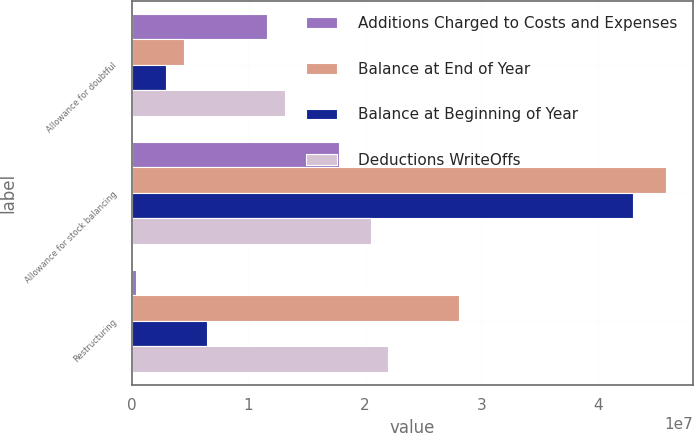Convert chart to OTSL. <chart><loc_0><loc_0><loc_500><loc_500><stacked_bar_chart><ecel><fcel>Allowance for doubtful<fcel>Allowance for stock balancing<fcel>Restructuring<nl><fcel>Additions Charged to Costs and Expenses<fcel>1.1611e+07<fcel>1.7761e+07<fcel>391000<nl><fcel>Balance at End of Year<fcel>4.519e+06<fcel>4.5876e+07<fcel>2.8097e+07<nl><fcel>Balance at Beginning of Year<fcel>2.949e+06<fcel>4.3059e+07<fcel>6.486e+06<nl><fcel>Deductions WriteOffs<fcel>1.3181e+07<fcel>2.0578e+07<fcel>2.2002e+07<nl></chart> 